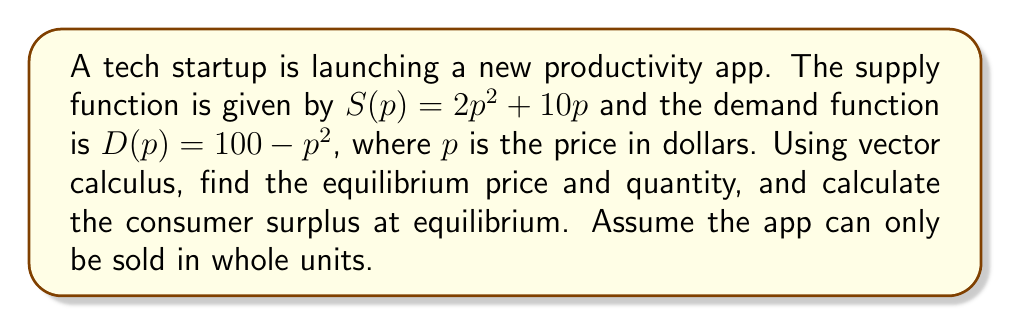What is the answer to this math problem? To solve this problem efficiently, we'll use vector calculus concepts:

1) First, we need to find the equilibrium point where supply equals demand:

   $$S(p) = D(p)$$
   $$2p^2 + 10p = 100 - p^2$$
   $$3p^2 + 10p - 100 = 0$$

2) This is a quadratic equation. We can solve it using the quadratic formula:

   $$p = \frac{-b \pm \sqrt{b^2 - 4ac}}{2a}$$

   Where $a=3$, $b=10$, and $c=-100$

   $$p = \frac{-10 \pm \sqrt{100 + 1200}}{6} = \frac{-10 \pm \sqrt{1300}}{6}$$

3) Solving this, we get $p \approx 5.88$ (rounded to 2 decimal places)

4) The equilibrium quantity can be found by plugging this price back into either the supply or demand function:

   $$Q = S(5.88) \approx 2(5.88)^2 + 10(5.88) \approx 127.94$$

5) Rounding to the nearest whole unit (as specified in the question), we get 128 units.

6) To calculate the consumer surplus, we need to integrate the difference between the demand curve and the equilibrium price from 0 to the equilibrium quantity:

   $$CS = \int_0^{5.88} (100 - p^2 - 5.88) dp$$

7) This integral can be solved as follows:

   $$CS = [100p - \frac{p^3}{3} - 5.88p]_0^{5.88}$$
   $$CS = (588 - 67.69 - 34.57) - (0 - 0 - 0) = 485.74$$

8) The consumer surplus is approximately $485.74.
Answer: The equilibrium price is $5.88, the equilibrium quantity is 128 units, and the consumer surplus at equilibrium is $485.74. 